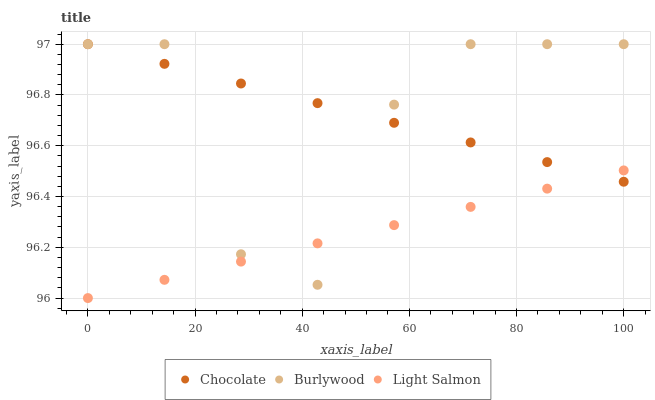Does Light Salmon have the minimum area under the curve?
Answer yes or no. Yes. Does Chocolate have the maximum area under the curve?
Answer yes or no. Yes. Does Chocolate have the minimum area under the curve?
Answer yes or no. No. Does Light Salmon have the maximum area under the curve?
Answer yes or no. No. Is Chocolate the smoothest?
Answer yes or no. Yes. Is Burlywood the roughest?
Answer yes or no. Yes. Is Light Salmon the smoothest?
Answer yes or no. No. Is Light Salmon the roughest?
Answer yes or no. No. Does Light Salmon have the lowest value?
Answer yes or no. Yes. Does Chocolate have the lowest value?
Answer yes or no. No. Does Chocolate have the highest value?
Answer yes or no. Yes. Does Light Salmon have the highest value?
Answer yes or no. No. Does Chocolate intersect Light Salmon?
Answer yes or no. Yes. Is Chocolate less than Light Salmon?
Answer yes or no. No. Is Chocolate greater than Light Salmon?
Answer yes or no. No. 